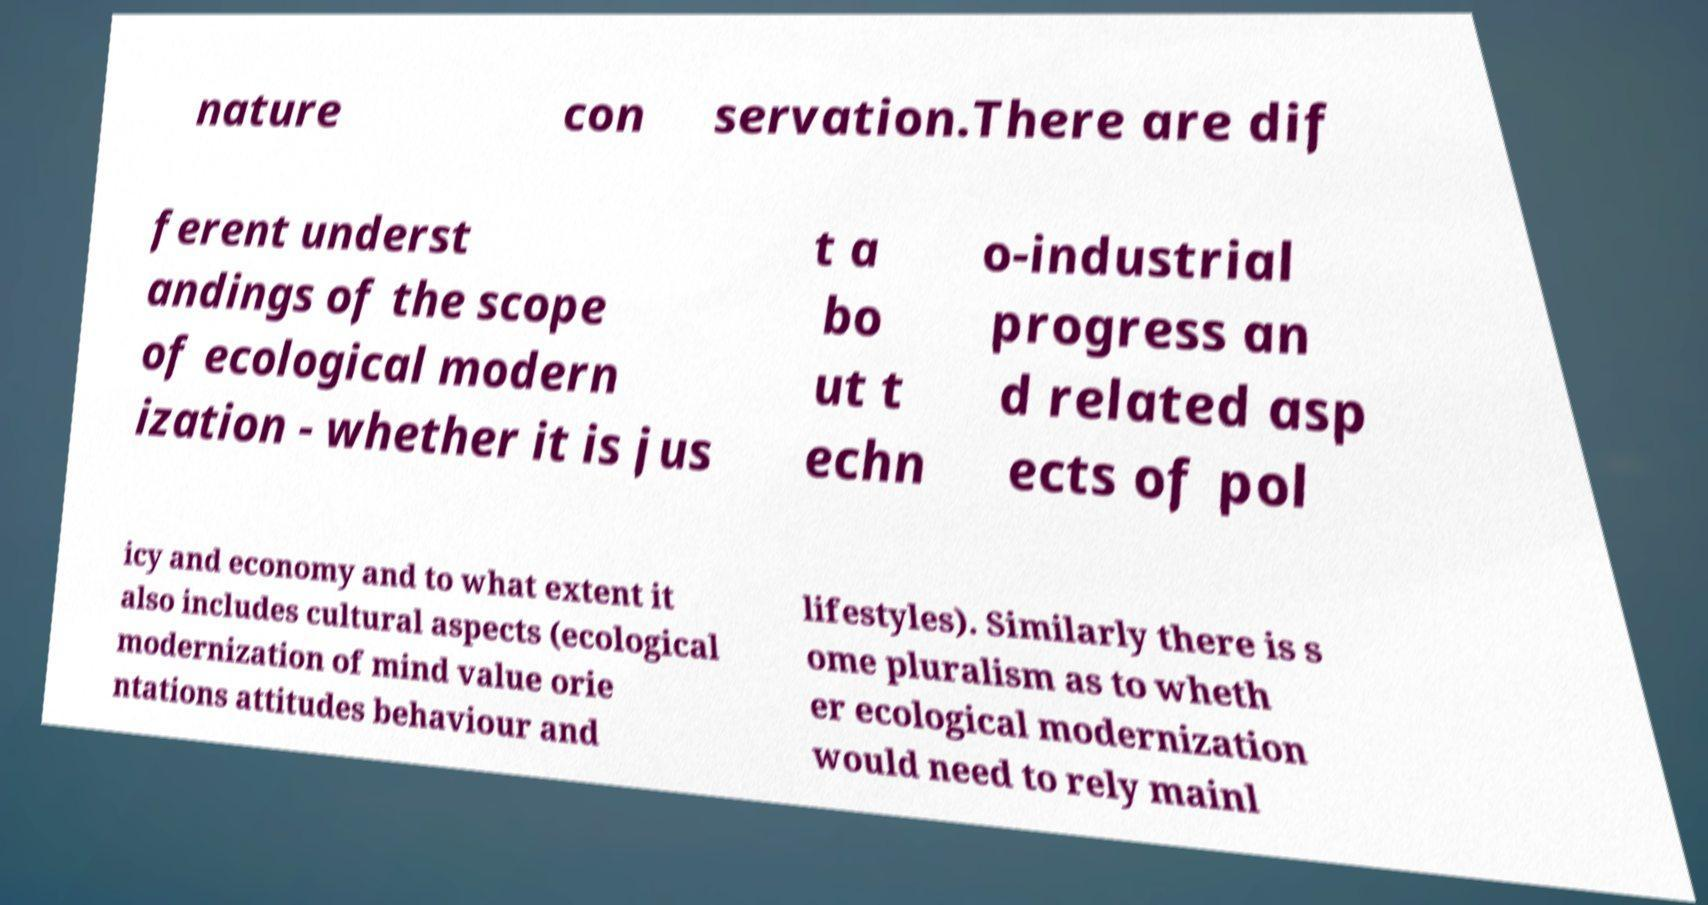Could you extract and type out the text from this image? nature con servation.There are dif ferent underst andings of the scope of ecological modern ization - whether it is jus t a bo ut t echn o-industrial progress an d related asp ects of pol icy and economy and to what extent it also includes cultural aspects (ecological modernization of mind value orie ntations attitudes behaviour and lifestyles). Similarly there is s ome pluralism as to wheth er ecological modernization would need to rely mainl 